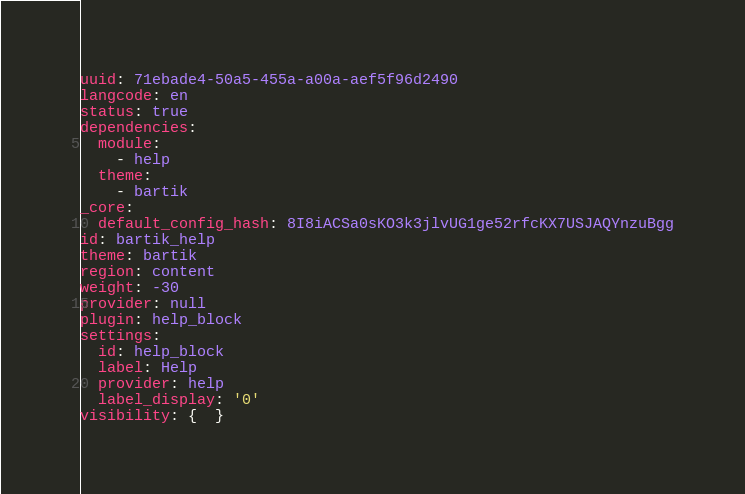<code> <loc_0><loc_0><loc_500><loc_500><_YAML_>uuid: 71ebade4-50a5-455a-a00a-aef5f96d2490
langcode: en
status: true
dependencies:
  module:
    - help
  theme:
    - bartik
_core:
  default_config_hash: 8I8iACSa0sKO3k3jlvUG1ge52rfcKX7USJAQYnzuBgg
id: bartik_help
theme: bartik
region: content
weight: -30
provider: null
plugin: help_block
settings:
  id: help_block
  label: Help
  provider: help
  label_display: '0'
visibility: {  }
</code> 